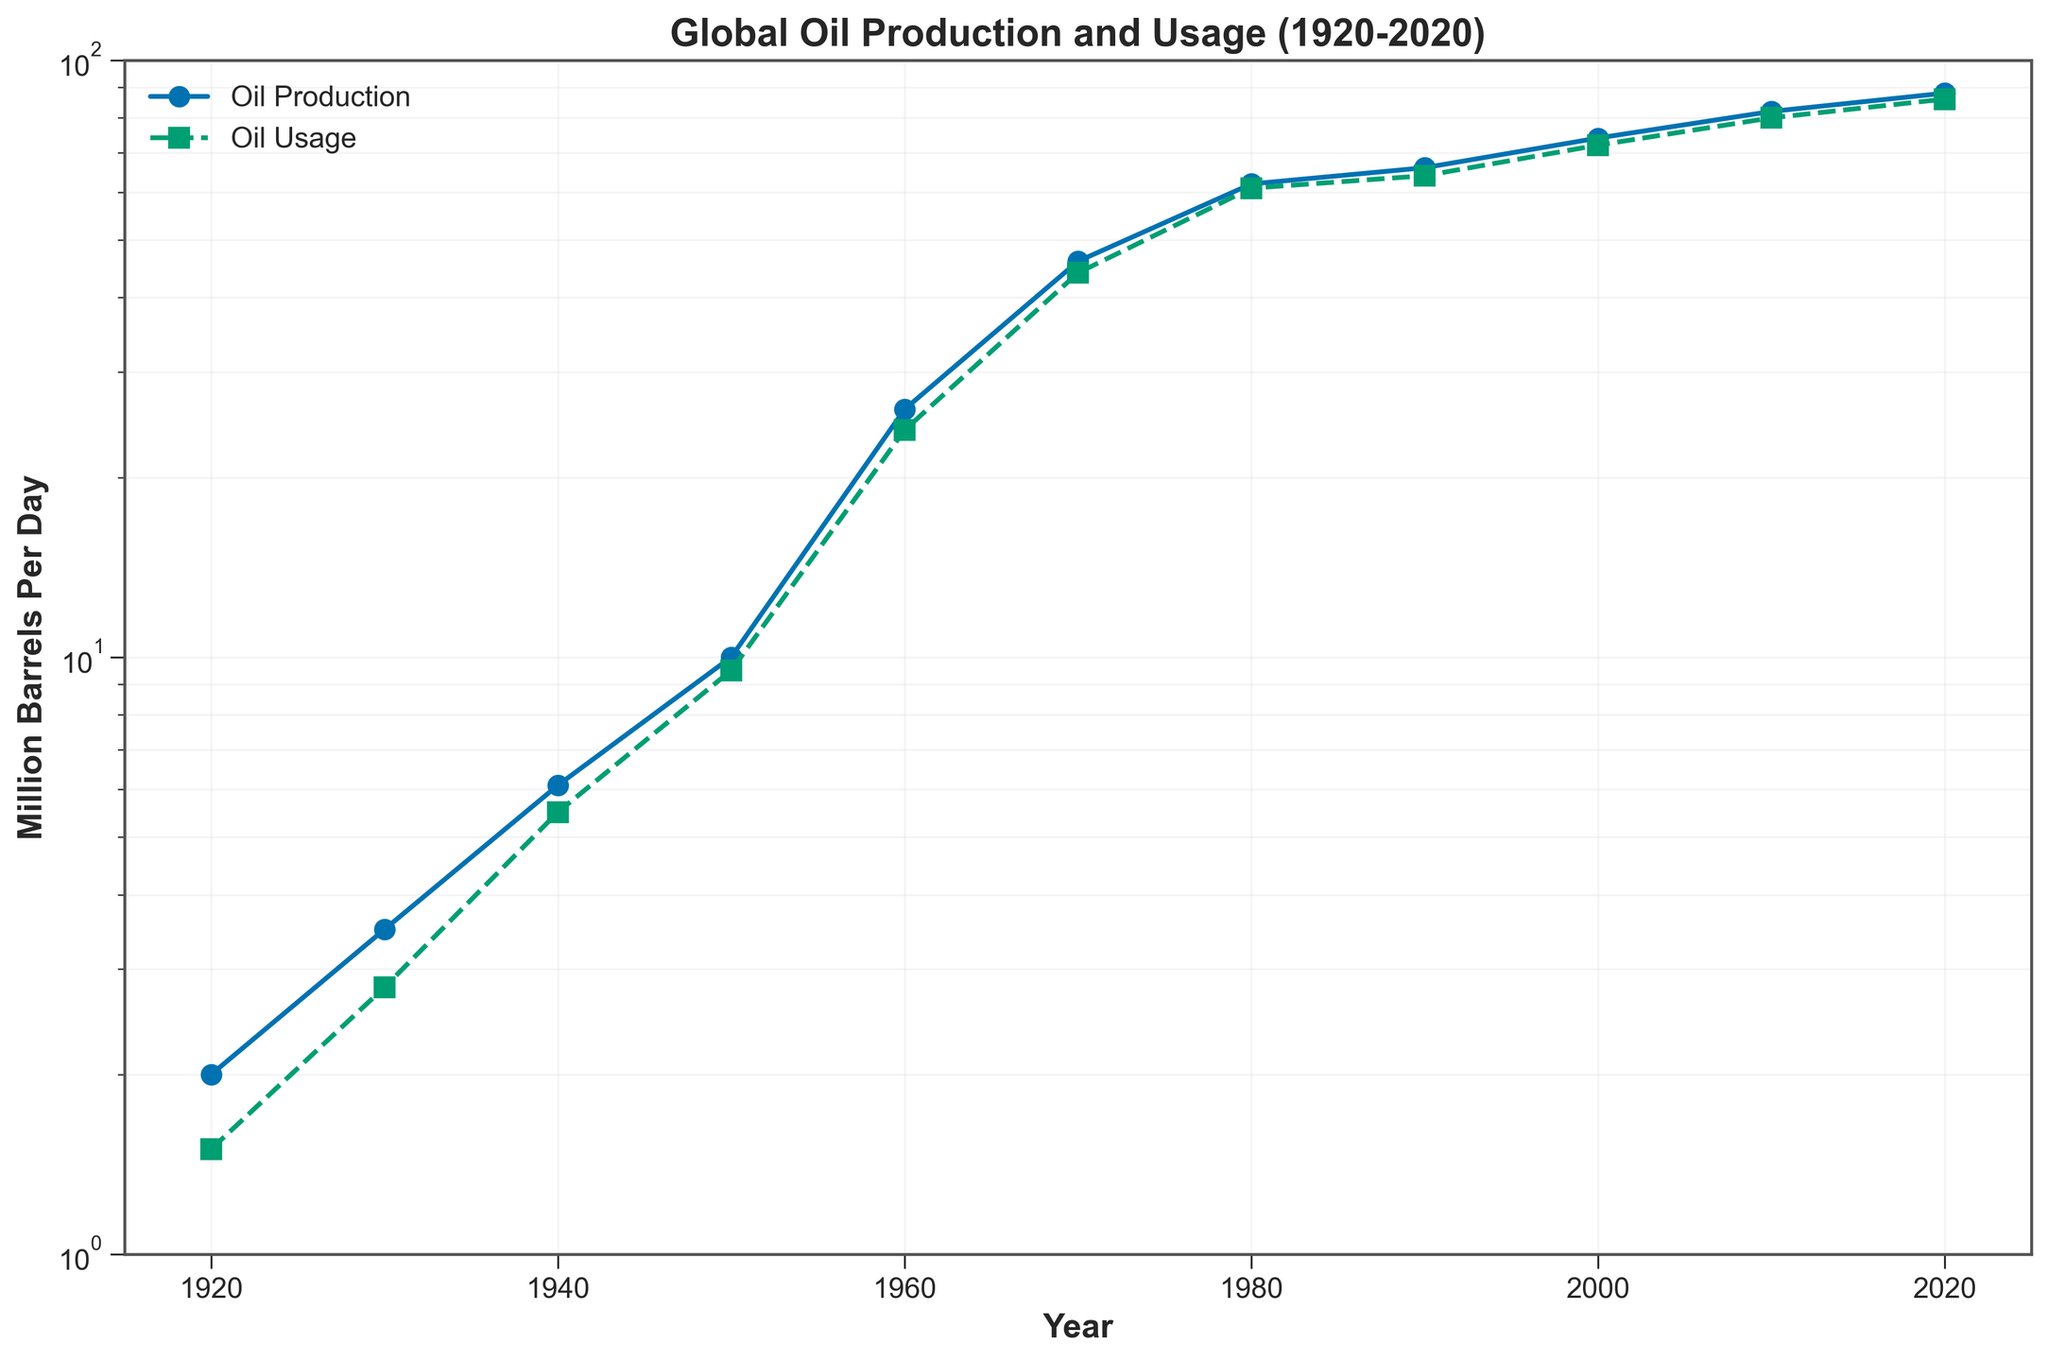What is the title of the plot? The title is usually located at the top of the plot and summarizes the subject of the visualization. Here, it's labeled 'Global Oil Production and Usage (1920-2020)'.
Answer: Global Oil Production and Usage (1920-2020) How is the y-axis of the plot scaled? The y-axis is labeled 'Million Barrels Per Day' and includes a 'log' notation, indicating it uses a logarithmic scale.
Answer: Logarithmic scale What's the y-axis range? By observing the y-axis, the minimum value is around 1 and the maximum is 100.
Answer: 1 to 100 How many data points are plotted for Global Oil Production? The lines are marked with circles at the data points. Counting these along the 'Oil Production' line gives us 11 points.
Answer: 11 In which year did Global Oil Usage first surpass 50 million barrels per day? By tracing the 'Oil Usage' line intersecting the 50 million barrels mark, it lies between 1960 and 1970. The data shows in 1970 it was 44 million but in 1980 it was 61 million. Thus, 1980 must be the year it first surpassed 50.
Answer: 1980 By how much did Global Oil Production increase from 1920 to 2020? Check the 'Oil Production' values in 1920 which is 2.0 and in 2020 which is 88.0; the difference is 88.0 - 2.0 = 86.0.
Answer: 86 million barrels per day What's the average Global Oil Usage per day for the years plotted? Summing all the values for 'Oil Usage' (1.5 + 2.8 + 5.5 + 9.5 + 24.0 + 44.0 + 61.0 + 64.0 + 72.0 + 80.0 + 86.0) and then dividing by the number of data points (11) gives: (450.3 / 11) ≈ 40.94.
Answer: About 40.94 million barrels per day Was there any period where Global Oil Production was equal to Global Oil Usage? On the 'Oil Production' and 'Usage' lines, check if they overlap or are identical at any point. In this plot, they never exactly match.
Answer: No Which had a steeper increase from 1950 to 1960, Global Oil Production or Global Oil Usage? Comparing the slope between 1950 and 1960 data points, 'Oil Production' increased from 10 to 26 (an increase of 16), while 'Oil Usage' increased from 9.5 to 24 (an increase of 14.5).
Answer: Global Oil Production What trend can you observe in Global Oil Production from 1920 to 2020? By observing the 'Oil Production' line, it steadily rises from 2.0 in 1920 to 88.0 in 2020, indicating a significant upward trend.
Answer: Steady increase 